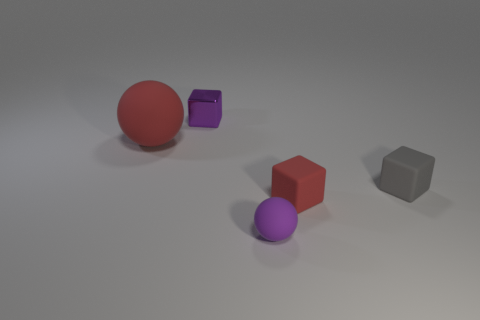Add 2 large cylinders. How many objects exist? 7 Subtract all spheres. How many objects are left? 3 Subtract 0 cyan cylinders. How many objects are left? 5 Subtract all matte balls. Subtract all brown matte spheres. How many objects are left? 3 Add 3 purple rubber things. How many purple rubber things are left? 4 Add 1 large red objects. How many large red objects exist? 2 